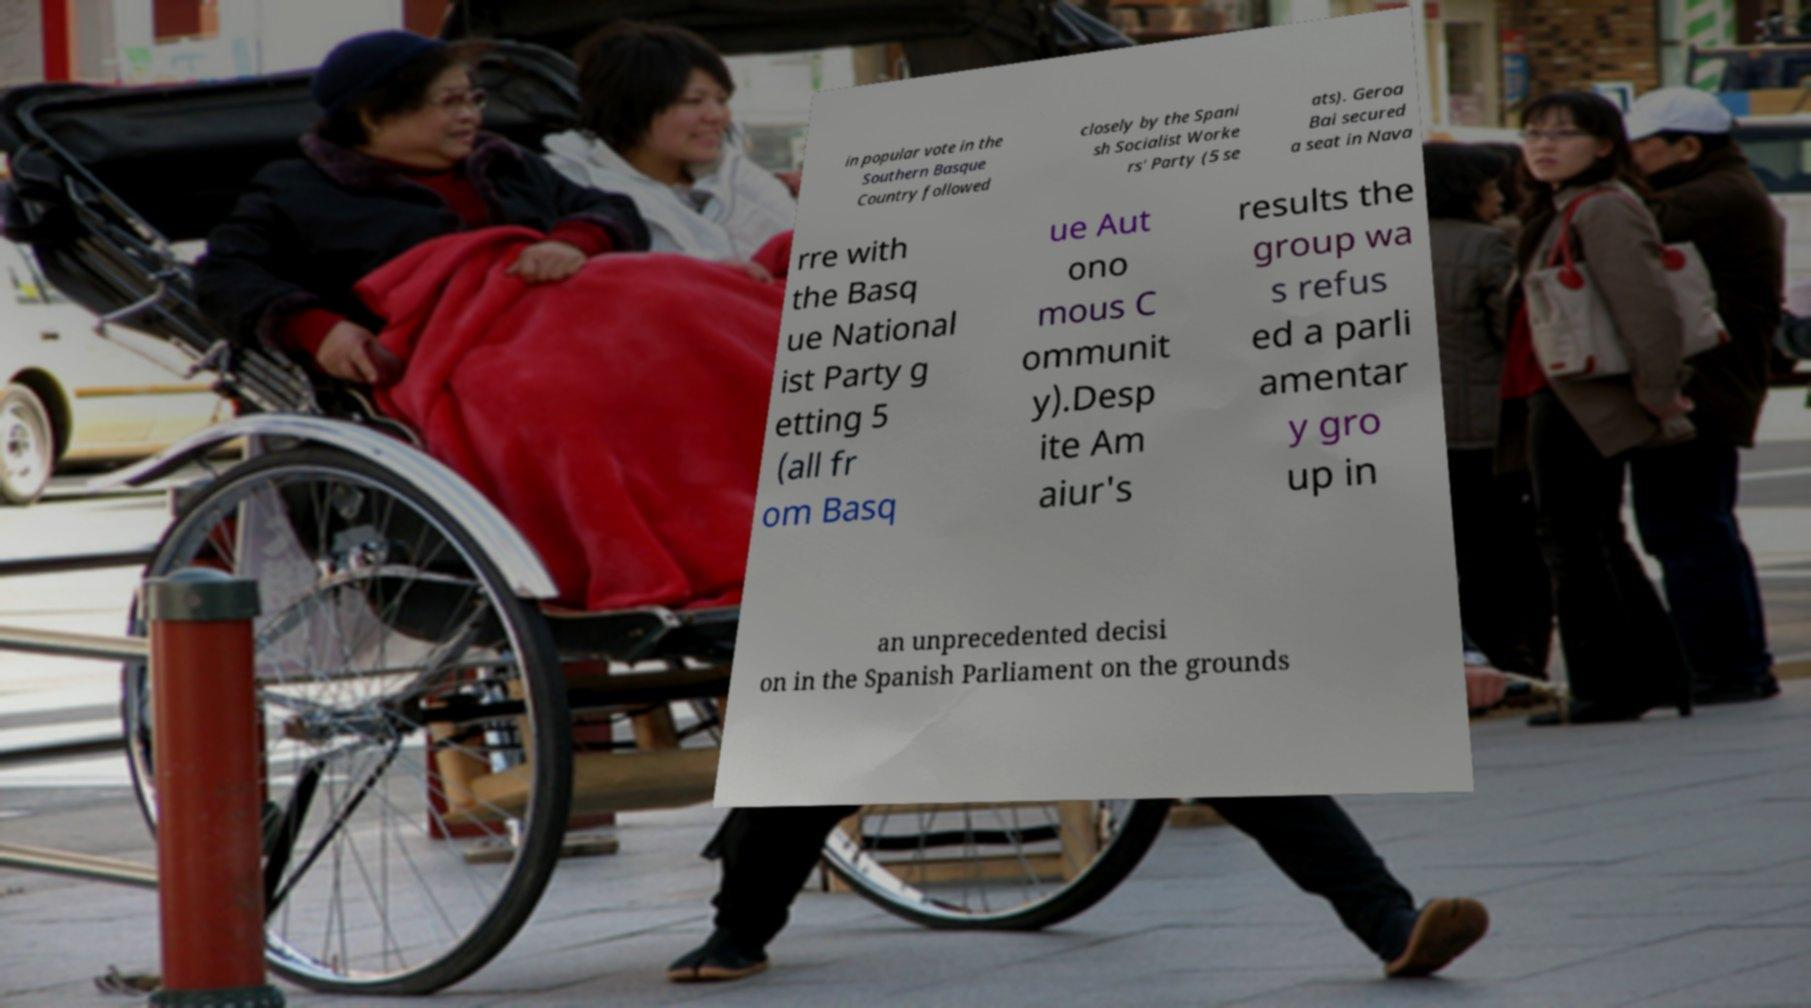For documentation purposes, I need the text within this image transcribed. Could you provide that? in popular vote in the Southern Basque Country followed closely by the Spani sh Socialist Worke rs' Party (5 se ats). Geroa Bai secured a seat in Nava rre with the Basq ue National ist Party g etting 5 (all fr om Basq ue Aut ono mous C ommunit y).Desp ite Am aiur's results the group wa s refus ed a parli amentar y gro up in an unprecedented decisi on in the Spanish Parliament on the grounds 